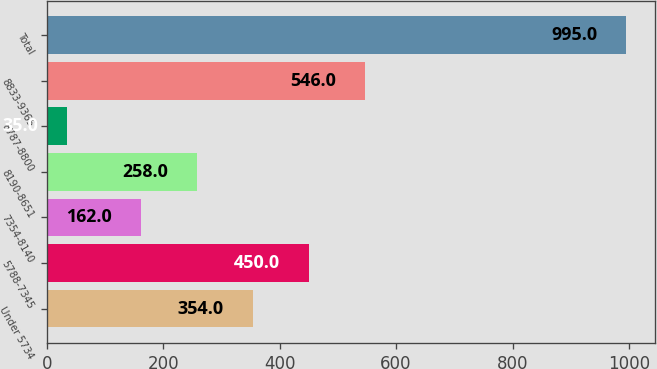<chart> <loc_0><loc_0><loc_500><loc_500><bar_chart><fcel>Under 5734<fcel>5788-7345<fcel>7354-8140<fcel>8190-8651<fcel>8787-8800<fcel>8833-9365<fcel>Total<nl><fcel>354<fcel>450<fcel>162<fcel>258<fcel>35<fcel>546<fcel>995<nl></chart> 